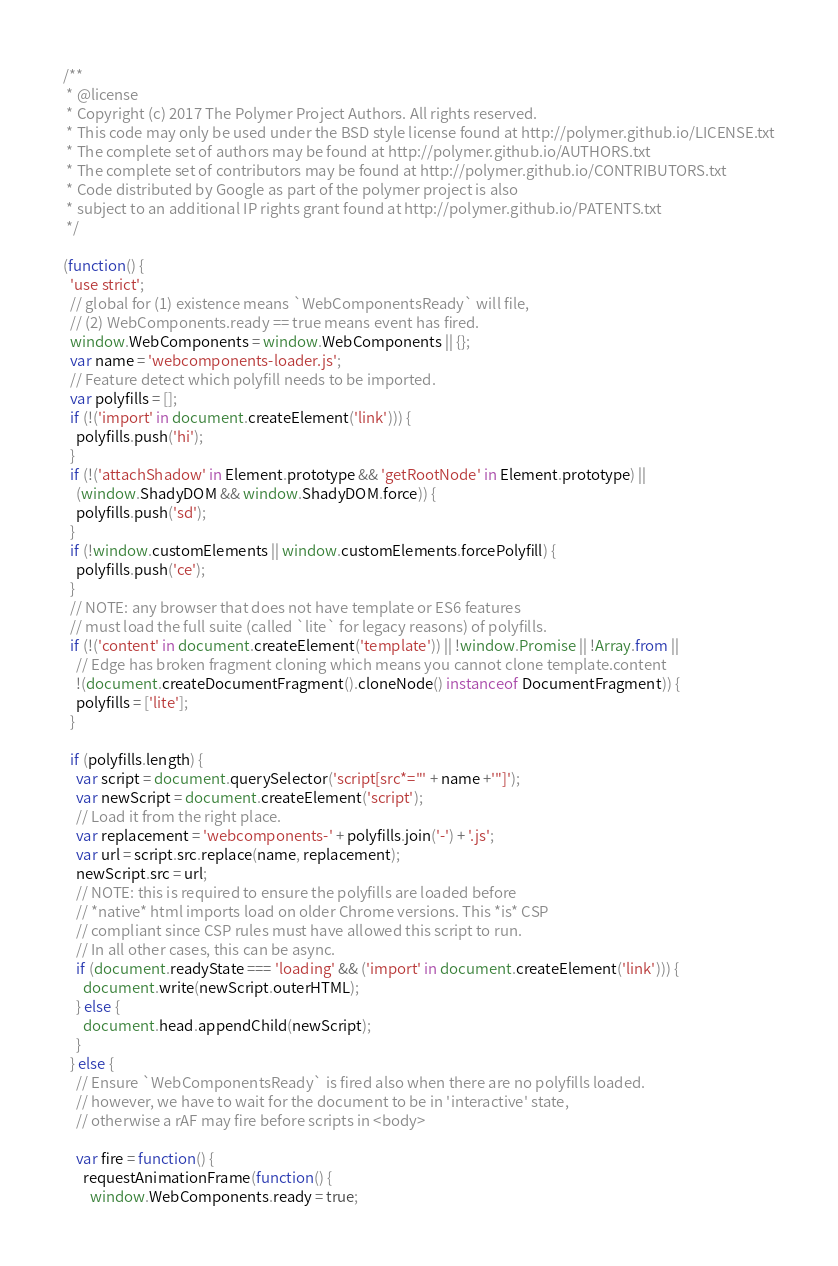Convert code to text. <code><loc_0><loc_0><loc_500><loc_500><_JavaScript_>/**
 * @license
 * Copyright (c) 2017 The Polymer Project Authors. All rights reserved.
 * This code may only be used under the BSD style license found at http://polymer.github.io/LICENSE.txt
 * The complete set of authors may be found at http://polymer.github.io/AUTHORS.txt
 * The complete set of contributors may be found at http://polymer.github.io/CONTRIBUTORS.txt
 * Code distributed by Google as part of the polymer project is also
 * subject to an additional IP rights grant found at http://polymer.github.io/PATENTS.txt
 */

(function() {
  'use strict';
  // global for (1) existence means `WebComponentsReady` will file,
  // (2) WebComponents.ready == true means event has fired.
  window.WebComponents = window.WebComponents || {};
  var name = 'webcomponents-loader.js';
  // Feature detect which polyfill needs to be imported.
  var polyfills = [];
  if (!('import' in document.createElement('link'))) {
    polyfills.push('hi');
  }
  if (!('attachShadow' in Element.prototype && 'getRootNode' in Element.prototype) ||
    (window.ShadyDOM && window.ShadyDOM.force)) {
    polyfills.push('sd');
  }
  if (!window.customElements || window.customElements.forcePolyfill) {
    polyfills.push('ce');
  }
  // NOTE: any browser that does not have template or ES6 features
  // must load the full suite (called `lite` for legacy reasons) of polyfills.
  if (!('content' in document.createElement('template')) || !window.Promise || !Array.from ||
    // Edge has broken fragment cloning which means you cannot clone template.content
    !(document.createDocumentFragment().cloneNode() instanceof DocumentFragment)) {
    polyfills = ['lite'];
  }

  if (polyfills.length) {
    var script = document.querySelector('script[src*="' + name +'"]');
    var newScript = document.createElement('script');
    // Load it from the right place.
    var replacement = 'webcomponents-' + polyfills.join('-') + '.js';
    var url = script.src.replace(name, replacement);
    newScript.src = url;
    // NOTE: this is required to ensure the polyfills are loaded before
    // *native* html imports load on older Chrome versions. This *is* CSP
    // compliant since CSP rules must have allowed this script to run.
    // In all other cases, this can be async.
    if (document.readyState === 'loading' && ('import' in document.createElement('link'))) {
      document.write(newScript.outerHTML);
    } else {
      document.head.appendChild(newScript);
    }
  } else {
    // Ensure `WebComponentsReady` is fired also when there are no polyfills loaded.
    // however, we have to wait for the document to be in 'interactive' state,
    // otherwise a rAF may fire before scripts in <body>

    var fire = function() {
      requestAnimationFrame(function() {
        window.WebComponents.ready = true;</code> 